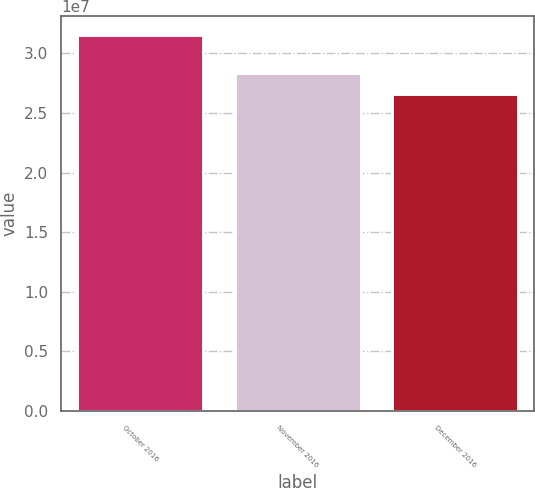Convert chart to OTSL. <chart><loc_0><loc_0><loc_500><loc_500><bar_chart><fcel>October 2016<fcel>November 2016<fcel>December 2016<nl><fcel>3.15451e+07<fcel>2.83811e+07<fcel>2.66125e+07<nl></chart> 